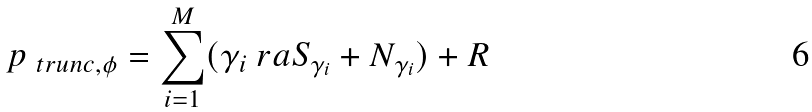<formula> <loc_0><loc_0><loc_500><loc_500>\L p _ { \ t r u n c , \phi } = \sum _ { i = 1 } ^ { M } ( \gamma _ { i } \ r a S _ { \gamma _ { i } } + N _ { \gamma _ { i } } ) + R</formula> 